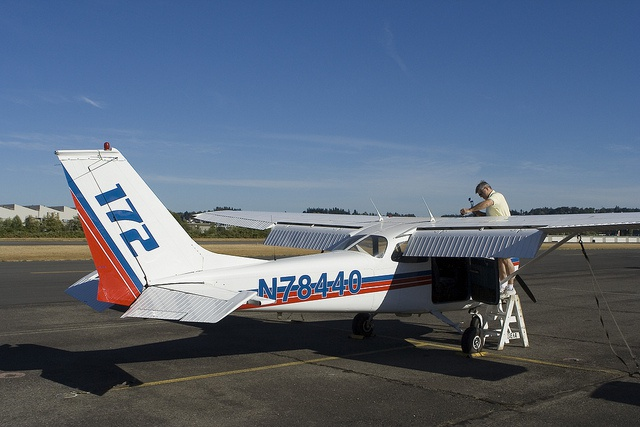Describe the objects in this image and their specific colors. I can see airplane in blue, lightgray, darkgray, black, and gray tones and people in blue, gray, beige, darkgray, and tan tones in this image. 